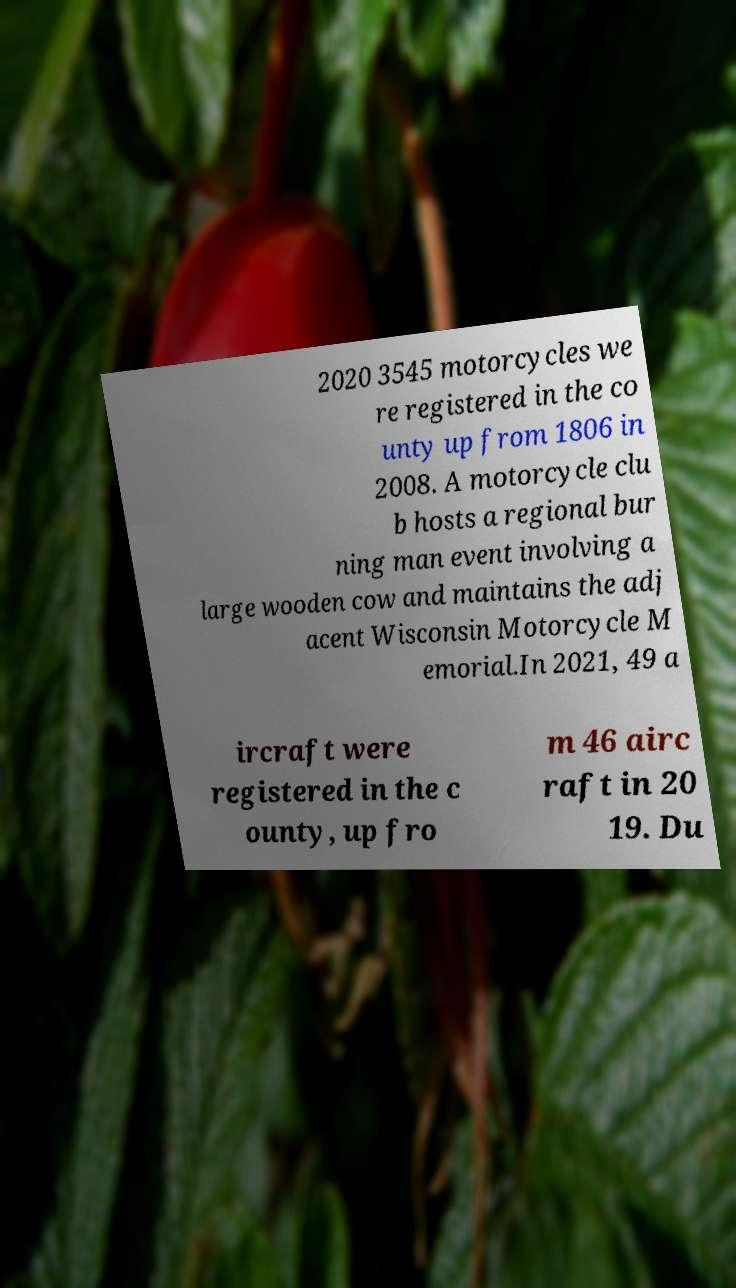I need the written content from this picture converted into text. Can you do that? 2020 3545 motorcycles we re registered in the co unty up from 1806 in 2008. A motorcycle clu b hosts a regional bur ning man event involving a large wooden cow and maintains the adj acent Wisconsin Motorcycle M emorial.In 2021, 49 a ircraft were registered in the c ounty, up fro m 46 airc raft in 20 19. Du 